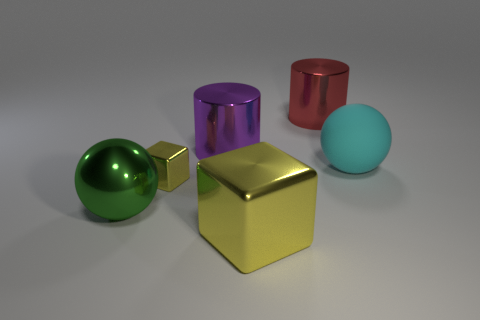Add 1 tiny yellow shiny cubes. How many objects exist? 7 Subtract all cubes. How many objects are left? 4 Add 4 large red cylinders. How many large red cylinders are left? 5 Add 5 large yellow objects. How many large yellow objects exist? 6 Subtract 1 green balls. How many objects are left? 5 Subtract all green metallic objects. Subtract all yellow cubes. How many objects are left? 3 